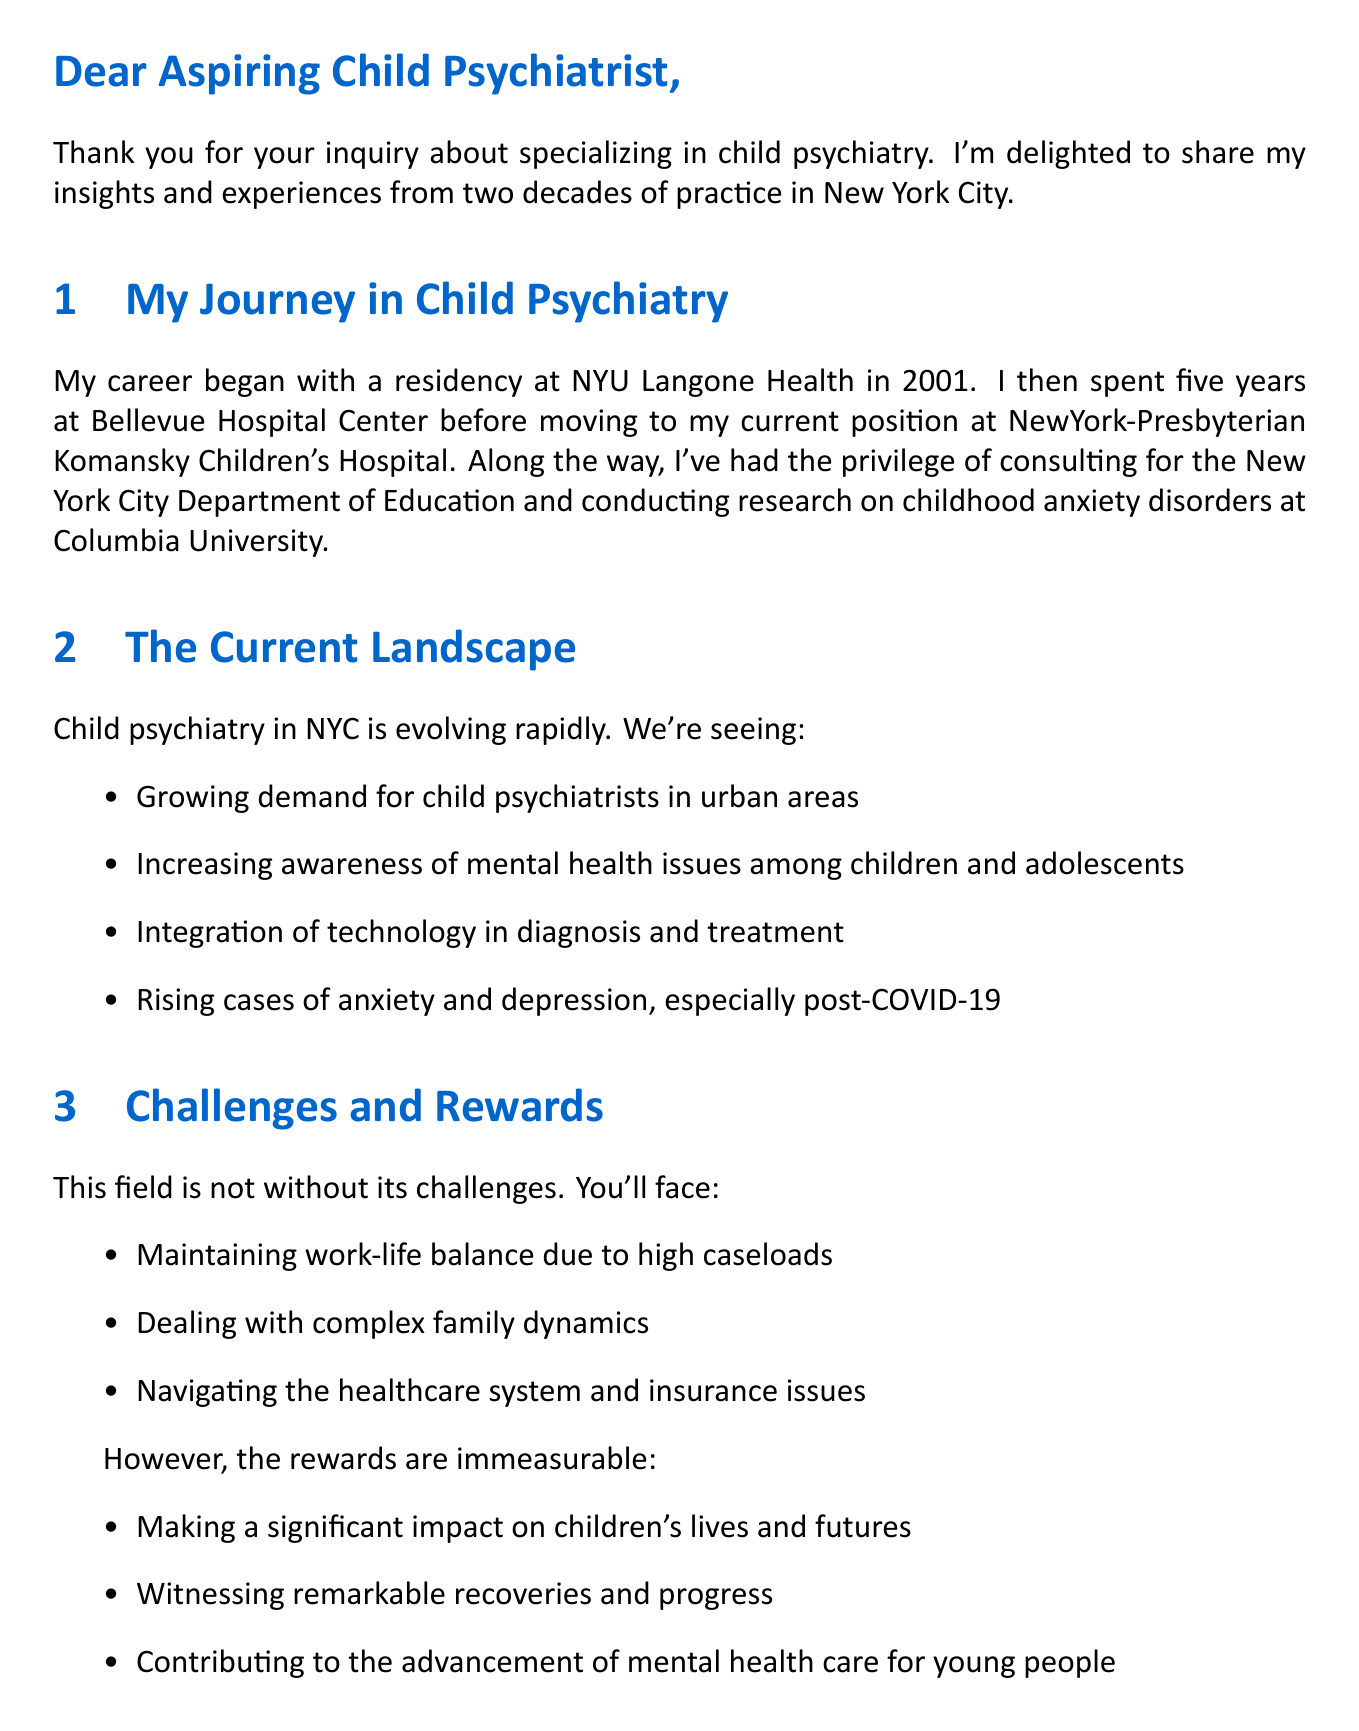What year did the author complete their residency? The author completed their residency at NYU Langone Health in 2001.
Answer: 2001 What is the name of the hospital where the author currently practices? The author is currently practicing at NewYork-Presbyterian Komansky Children's Hospital.
Answer: NewYork-Presbyterian Komansky Children's Hospital What is a major challenge mentioned in the document? One of the challenges mentioned is maintaining work-life balance due to high caseloads.
Answer: Maintaining work-life balance What type of courses should a medical student focus on to prepare for child psychiatry? The document advises focusing on child development courses during medical school.
Answer: Child development courses What is one reward of working in child psychiatry according to the letter? According to the letter, a reward of working in child psychiatry is making a significant impact on children's lives and futures.
Answer: Making a significant impact on children's lives What organization is suggested for continued education? The author suggests attending annual meetings of the American Academy of Child and Adolescent Psychiatry.
Answer: American Academy of Child and Adolescent Psychiatry What issue has seen a rise in cases among children mentioned in the insights? The document mentions a rising case of anxiety and depression in children, especially post-COVID-19.
Answer: Anxiety and depression What is a recommended step after residency for those specializing in child psychiatry? The document recommends considering a fellowship in child and adolescent psychiatry after residency.
Answer: Fellowship in child and adolescent psychiatry 